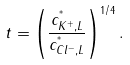<formula> <loc_0><loc_0><loc_500><loc_500>t = \left ( \frac { c ^ { ^ { * } } _ { K ^ { + } , L } } { c ^ { ^ { * } } _ { C l ^ { - } , L } } \right ) ^ { 1 / 4 } .</formula> 